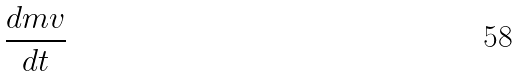Convert formula to latex. <formula><loc_0><loc_0><loc_500><loc_500>\frac { d m v } { d t }</formula> 